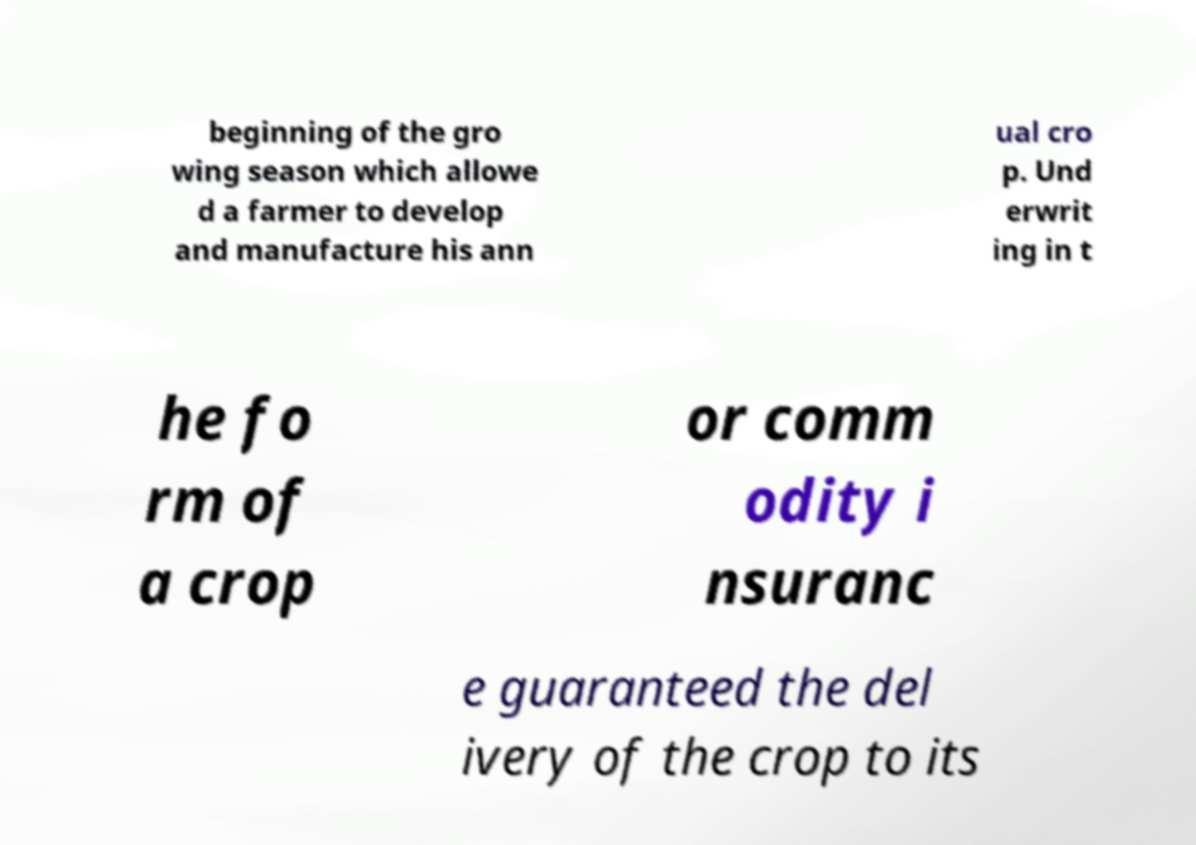Can you read and provide the text displayed in the image?This photo seems to have some interesting text. Can you extract and type it out for me? beginning of the gro wing season which allowe d a farmer to develop and manufacture his ann ual cro p. Und erwrit ing in t he fo rm of a crop or comm odity i nsuranc e guaranteed the del ivery of the crop to its 